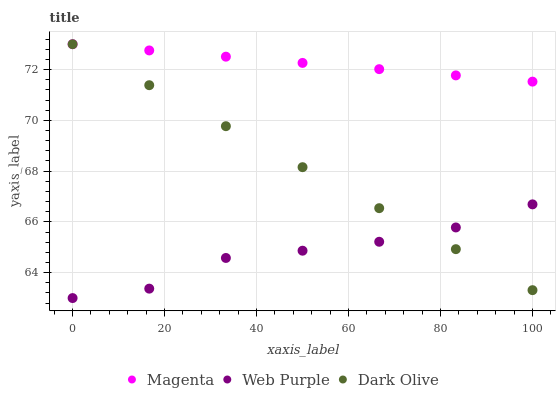Does Web Purple have the minimum area under the curve?
Answer yes or no. Yes. Does Magenta have the maximum area under the curve?
Answer yes or no. Yes. Does Dark Olive have the minimum area under the curve?
Answer yes or no. No. Does Dark Olive have the maximum area under the curve?
Answer yes or no. No. Is Magenta the smoothest?
Answer yes or no. Yes. Is Web Purple the roughest?
Answer yes or no. Yes. Is Dark Olive the smoothest?
Answer yes or no. No. Is Dark Olive the roughest?
Answer yes or no. No. Does Web Purple have the lowest value?
Answer yes or no. Yes. Does Dark Olive have the lowest value?
Answer yes or no. No. Does Dark Olive have the highest value?
Answer yes or no. Yes. Does Web Purple have the highest value?
Answer yes or no. No. Is Web Purple less than Magenta?
Answer yes or no. Yes. Is Magenta greater than Web Purple?
Answer yes or no. Yes. Does Web Purple intersect Dark Olive?
Answer yes or no. Yes. Is Web Purple less than Dark Olive?
Answer yes or no. No. Is Web Purple greater than Dark Olive?
Answer yes or no. No. Does Web Purple intersect Magenta?
Answer yes or no. No. 